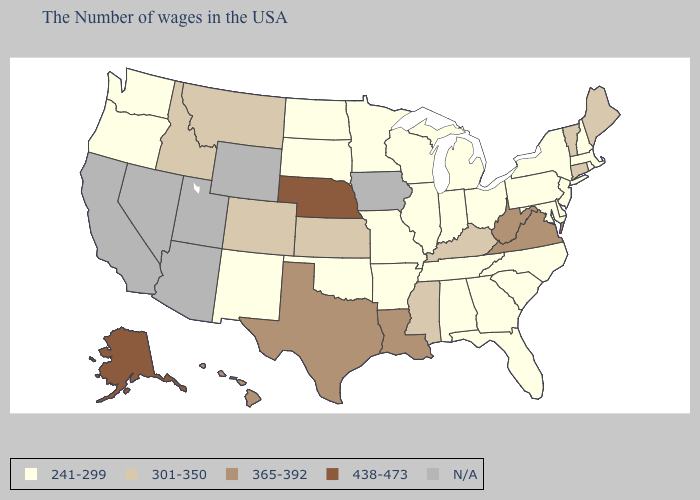Name the states that have a value in the range 241-299?
Be succinct. Massachusetts, Rhode Island, New Hampshire, New York, New Jersey, Delaware, Maryland, Pennsylvania, North Carolina, South Carolina, Ohio, Florida, Georgia, Michigan, Indiana, Alabama, Tennessee, Wisconsin, Illinois, Missouri, Arkansas, Minnesota, Oklahoma, South Dakota, North Dakota, New Mexico, Washington, Oregon. Does Washington have the lowest value in the West?
Be succinct. Yes. Is the legend a continuous bar?
Concise answer only. No. Does the first symbol in the legend represent the smallest category?
Answer briefly. Yes. How many symbols are there in the legend?
Answer briefly. 5. Does the map have missing data?
Quick response, please. Yes. Which states have the lowest value in the USA?
Quick response, please. Massachusetts, Rhode Island, New Hampshire, New York, New Jersey, Delaware, Maryland, Pennsylvania, North Carolina, South Carolina, Ohio, Florida, Georgia, Michigan, Indiana, Alabama, Tennessee, Wisconsin, Illinois, Missouri, Arkansas, Minnesota, Oklahoma, South Dakota, North Dakota, New Mexico, Washington, Oregon. Is the legend a continuous bar?
Keep it brief. No. What is the highest value in states that border Washington?
Give a very brief answer. 301-350. Name the states that have a value in the range N/A?
Concise answer only. Iowa, Wyoming, Utah, Arizona, Nevada, California. Does the first symbol in the legend represent the smallest category?
Quick response, please. Yes. Name the states that have a value in the range 438-473?
Concise answer only. Nebraska, Alaska. Does Georgia have the lowest value in the South?
Concise answer only. Yes. What is the highest value in the USA?
Give a very brief answer. 438-473. 